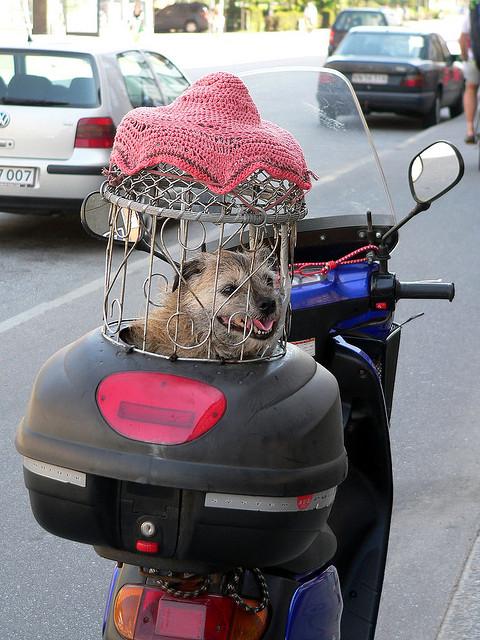How many suitcases are there?
Answer briefly. 0. What is the last numbers in the license plate?
Write a very short answer. 007. Is the dog in a cage?
Give a very brief answer. Yes. What kind of vehicle is the dog riding in?
Short answer required. Scooter. 